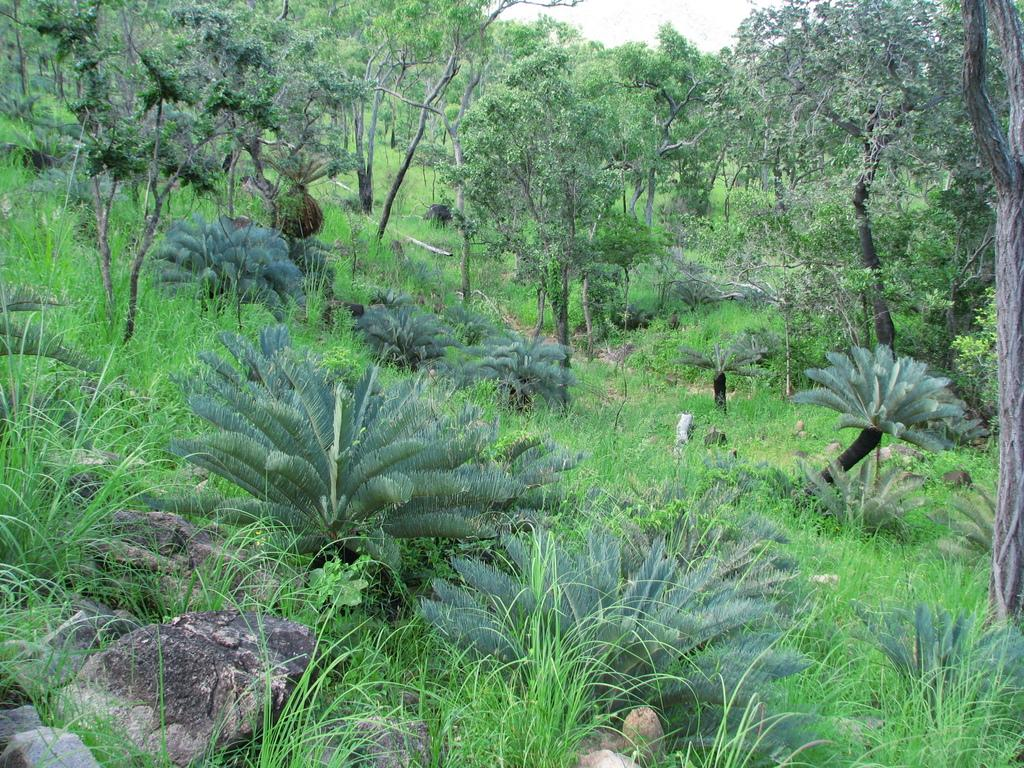What type of environment is depicted in the image? The image is taken in a forest. What are the main features of the forest? There are many trees and grass visible in the image. Are there any other natural elements present in the image? Yes, rocks are present in the image. What can be seen in the sky in the image? The sky is visible in the image. What type of engine can be seen powering a vehicle in the image? There is no vehicle or engine present in the image; it is a forest scene with trees, grass, rocks, and the sky. 